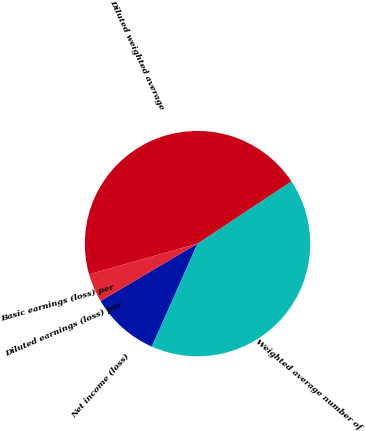Convert chart to OTSL. <chart><loc_0><loc_0><loc_500><loc_500><pie_chart><fcel>Net income (loss)<fcel>Weighted average number of<fcel>Diluted weighted average<fcel>Basic earnings (loss) per<fcel>Diluted earnings (loss) per<nl><fcel>9.86%<fcel>40.96%<fcel>45.07%<fcel>0.0%<fcel>4.11%<nl></chart> 